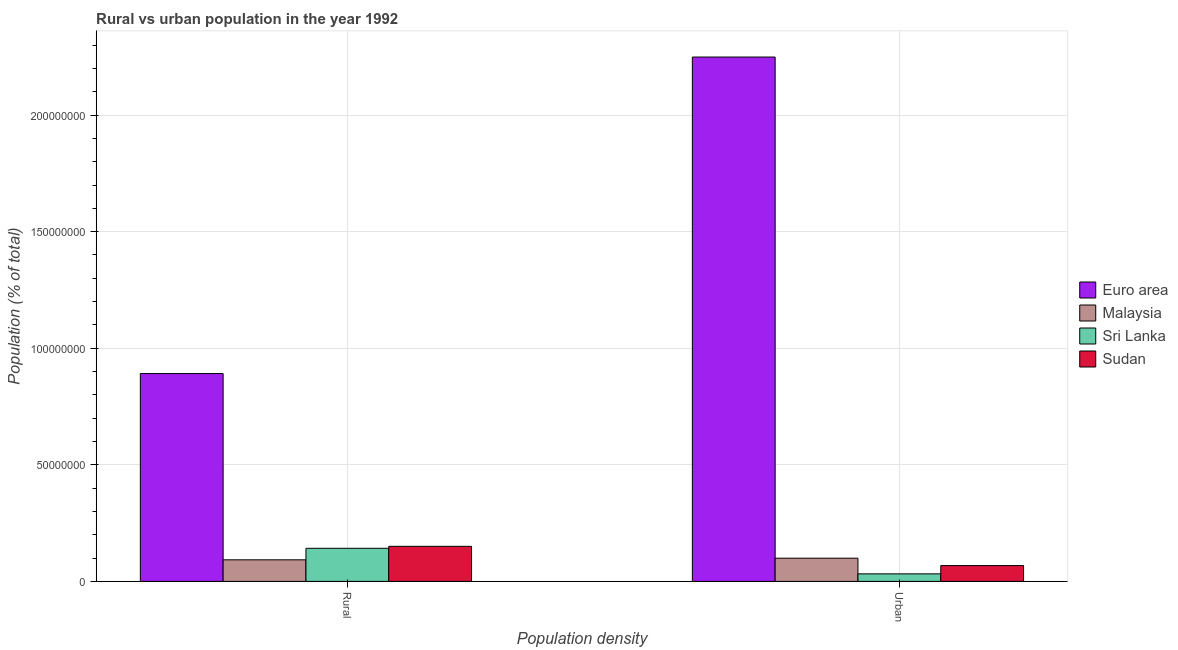How many different coloured bars are there?
Keep it short and to the point. 4. Are the number of bars per tick equal to the number of legend labels?
Provide a short and direct response. Yes. Are the number of bars on each tick of the X-axis equal?
Offer a terse response. Yes. What is the label of the 1st group of bars from the left?
Your response must be concise. Rural. What is the rural population density in Malaysia?
Offer a terse response. 9.25e+06. Across all countries, what is the maximum rural population density?
Your answer should be very brief. 8.91e+07. Across all countries, what is the minimum rural population density?
Offer a very short reply. 9.25e+06. In which country was the urban population density minimum?
Provide a succinct answer. Sri Lanka. What is the total urban population density in the graph?
Your answer should be compact. 2.45e+08. What is the difference between the urban population density in Sri Lanka and that in Sudan?
Offer a terse response. -3.56e+06. What is the difference between the urban population density in Sudan and the rural population density in Sri Lanka?
Offer a very short reply. -7.41e+06. What is the average rural population density per country?
Offer a very short reply. 3.19e+07. What is the difference between the rural population density and urban population density in Euro area?
Make the answer very short. -1.36e+08. In how many countries, is the rural population density greater than 30000000 %?
Provide a succinct answer. 1. What is the ratio of the urban population density in Malaysia to that in Sudan?
Offer a terse response. 1.47. Is the rural population density in Malaysia less than that in Sri Lanka?
Provide a short and direct response. Yes. In how many countries, is the urban population density greater than the average urban population density taken over all countries?
Your answer should be compact. 1. What does the 3rd bar from the left in Urban represents?
Ensure brevity in your answer.  Sri Lanka. What does the 2nd bar from the right in Urban represents?
Your answer should be compact. Sri Lanka. Are all the bars in the graph horizontal?
Make the answer very short. No. What is the difference between two consecutive major ticks on the Y-axis?
Offer a terse response. 5.00e+07. Does the graph contain any zero values?
Provide a succinct answer. No. How many legend labels are there?
Make the answer very short. 4. What is the title of the graph?
Provide a succinct answer. Rural vs urban population in the year 1992. What is the label or title of the X-axis?
Give a very brief answer. Population density. What is the label or title of the Y-axis?
Your response must be concise. Population (% of total). What is the Population (% of total) of Euro area in Rural?
Make the answer very short. 8.91e+07. What is the Population (% of total) of Malaysia in Rural?
Your response must be concise. 9.25e+06. What is the Population (% of total) in Sri Lanka in Rural?
Keep it short and to the point. 1.42e+07. What is the Population (% of total) in Sudan in Rural?
Your response must be concise. 1.50e+07. What is the Population (% of total) of Euro area in Urban?
Give a very brief answer. 2.25e+08. What is the Population (% of total) of Malaysia in Urban?
Provide a succinct answer. 9.95e+06. What is the Population (% of total) of Sri Lanka in Urban?
Offer a very short reply. 3.23e+06. What is the Population (% of total) in Sudan in Urban?
Ensure brevity in your answer.  6.79e+06. Across all Population density, what is the maximum Population (% of total) in Euro area?
Offer a terse response. 2.25e+08. Across all Population density, what is the maximum Population (% of total) in Malaysia?
Provide a short and direct response. 9.95e+06. Across all Population density, what is the maximum Population (% of total) in Sri Lanka?
Make the answer very short. 1.42e+07. Across all Population density, what is the maximum Population (% of total) in Sudan?
Offer a very short reply. 1.50e+07. Across all Population density, what is the minimum Population (% of total) of Euro area?
Ensure brevity in your answer.  8.91e+07. Across all Population density, what is the minimum Population (% of total) in Malaysia?
Make the answer very short. 9.25e+06. Across all Population density, what is the minimum Population (% of total) in Sri Lanka?
Make the answer very short. 3.23e+06. Across all Population density, what is the minimum Population (% of total) of Sudan?
Your answer should be very brief. 6.79e+06. What is the total Population (% of total) of Euro area in the graph?
Your answer should be compact. 3.14e+08. What is the total Population (% of total) in Malaysia in the graph?
Your answer should be very brief. 1.92e+07. What is the total Population (% of total) in Sri Lanka in the graph?
Your response must be concise. 1.74e+07. What is the total Population (% of total) in Sudan in the graph?
Make the answer very short. 2.18e+07. What is the difference between the Population (% of total) of Euro area in Rural and that in Urban?
Your response must be concise. -1.36e+08. What is the difference between the Population (% of total) of Malaysia in Rural and that in Urban?
Provide a succinct answer. -6.97e+05. What is the difference between the Population (% of total) of Sri Lanka in Rural and that in Urban?
Provide a short and direct response. 1.10e+07. What is the difference between the Population (% of total) in Sudan in Rural and that in Urban?
Keep it short and to the point. 8.25e+06. What is the difference between the Population (% of total) of Euro area in Rural and the Population (% of total) of Malaysia in Urban?
Ensure brevity in your answer.  7.92e+07. What is the difference between the Population (% of total) in Euro area in Rural and the Population (% of total) in Sri Lanka in Urban?
Offer a terse response. 8.59e+07. What is the difference between the Population (% of total) of Euro area in Rural and the Population (% of total) of Sudan in Urban?
Offer a very short reply. 8.24e+07. What is the difference between the Population (% of total) in Malaysia in Rural and the Population (% of total) in Sri Lanka in Urban?
Make the answer very short. 6.02e+06. What is the difference between the Population (% of total) of Malaysia in Rural and the Population (% of total) of Sudan in Urban?
Give a very brief answer. 2.47e+06. What is the difference between the Population (% of total) of Sri Lanka in Rural and the Population (% of total) of Sudan in Urban?
Your answer should be compact. 7.41e+06. What is the average Population (% of total) in Euro area per Population density?
Keep it short and to the point. 1.57e+08. What is the average Population (% of total) of Malaysia per Population density?
Your answer should be compact. 9.60e+06. What is the average Population (% of total) of Sri Lanka per Population density?
Your answer should be compact. 8.71e+06. What is the average Population (% of total) of Sudan per Population density?
Make the answer very short. 1.09e+07. What is the difference between the Population (% of total) of Euro area and Population (% of total) of Malaysia in Rural?
Give a very brief answer. 7.99e+07. What is the difference between the Population (% of total) in Euro area and Population (% of total) in Sri Lanka in Rural?
Offer a very short reply. 7.49e+07. What is the difference between the Population (% of total) in Euro area and Population (% of total) in Sudan in Rural?
Provide a short and direct response. 7.41e+07. What is the difference between the Population (% of total) of Malaysia and Population (% of total) of Sri Lanka in Rural?
Make the answer very short. -4.94e+06. What is the difference between the Population (% of total) of Malaysia and Population (% of total) of Sudan in Rural?
Give a very brief answer. -5.78e+06. What is the difference between the Population (% of total) of Sri Lanka and Population (% of total) of Sudan in Rural?
Give a very brief answer. -8.39e+05. What is the difference between the Population (% of total) of Euro area and Population (% of total) of Malaysia in Urban?
Your answer should be compact. 2.15e+08. What is the difference between the Population (% of total) of Euro area and Population (% of total) of Sri Lanka in Urban?
Your response must be concise. 2.22e+08. What is the difference between the Population (% of total) of Euro area and Population (% of total) of Sudan in Urban?
Provide a short and direct response. 2.18e+08. What is the difference between the Population (% of total) in Malaysia and Population (% of total) in Sri Lanka in Urban?
Give a very brief answer. 6.72e+06. What is the difference between the Population (% of total) of Malaysia and Population (% of total) of Sudan in Urban?
Your answer should be very brief. 3.16e+06. What is the difference between the Population (% of total) in Sri Lanka and Population (% of total) in Sudan in Urban?
Your answer should be compact. -3.56e+06. What is the ratio of the Population (% of total) of Euro area in Rural to that in Urban?
Offer a very short reply. 0.4. What is the ratio of the Population (% of total) in Malaysia in Rural to that in Urban?
Give a very brief answer. 0.93. What is the ratio of the Population (% of total) in Sri Lanka in Rural to that in Urban?
Provide a short and direct response. 4.39. What is the ratio of the Population (% of total) of Sudan in Rural to that in Urban?
Offer a terse response. 2.22. What is the difference between the highest and the second highest Population (% of total) of Euro area?
Ensure brevity in your answer.  1.36e+08. What is the difference between the highest and the second highest Population (% of total) in Malaysia?
Your answer should be compact. 6.97e+05. What is the difference between the highest and the second highest Population (% of total) in Sri Lanka?
Provide a short and direct response. 1.10e+07. What is the difference between the highest and the second highest Population (% of total) of Sudan?
Ensure brevity in your answer.  8.25e+06. What is the difference between the highest and the lowest Population (% of total) in Euro area?
Ensure brevity in your answer.  1.36e+08. What is the difference between the highest and the lowest Population (% of total) in Malaysia?
Ensure brevity in your answer.  6.97e+05. What is the difference between the highest and the lowest Population (% of total) in Sri Lanka?
Your answer should be very brief. 1.10e+07. What is the difference between the highest and the lowest Population (% of total) of Sudan?
Your answer should be compact. 8.25e+06. 